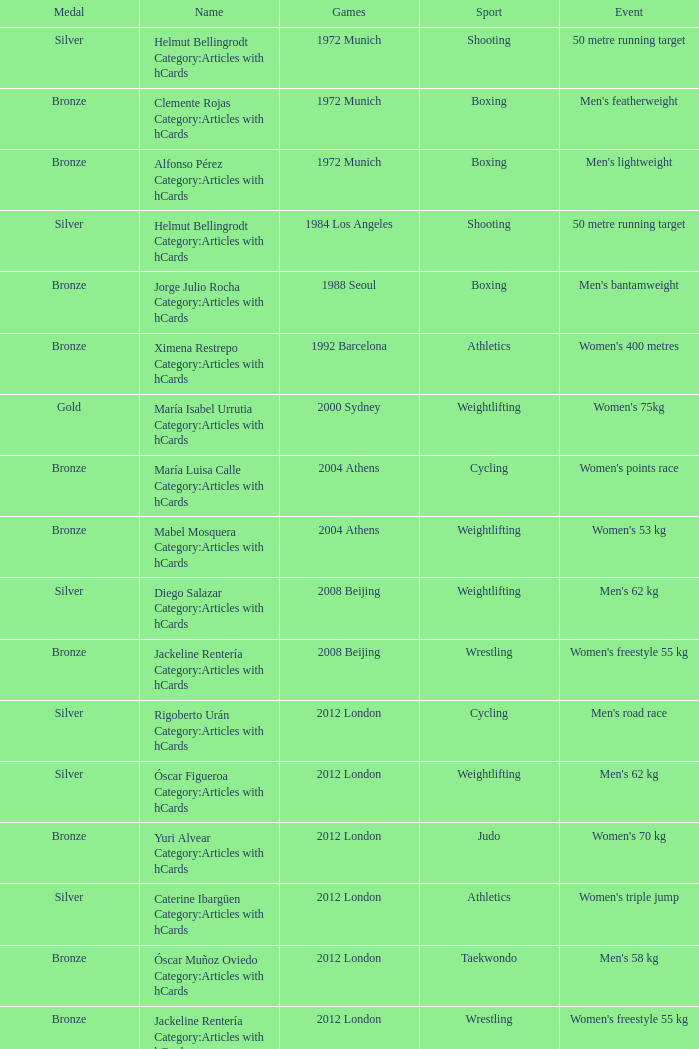During the 2008 beijing games, which wrestling event was held? Women's freestyle 55 kg. 